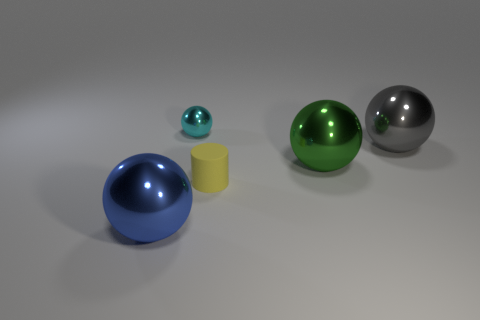Subtract 1 balls. How many balls are left? 3 Add 4 balls. How many objects exist? 9 Subtract all cylinders. How many objects are left? 4 Add 4 big green metal spheres. How many big green metal spheres exist? 5 Subtract 0 yellow blocks. How many objects are left? 5 Subtract all small green metal blocks. Subtract all yellow things. How many objects are left? 4 Add 2 cylinders. How many cylinders are left? 3 